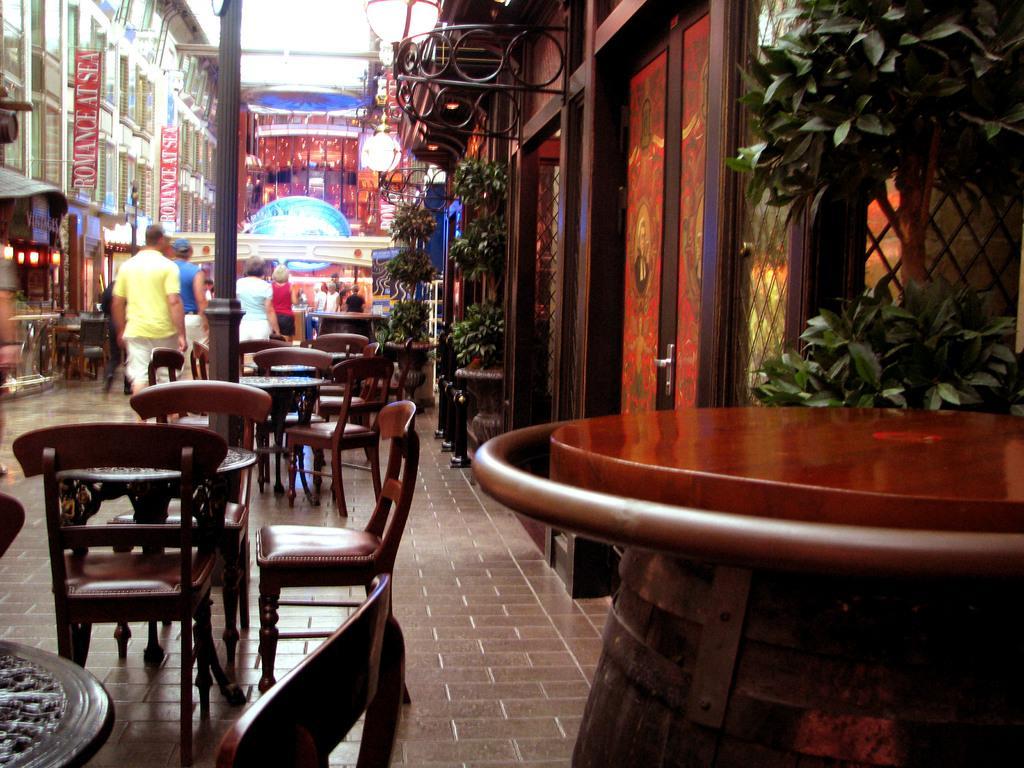In one or two sentences, can you explain what this image depicts? In this picture we can see people, chairs and tables on the ground, here we can see buildings, plants, lights, posters and some objects. 